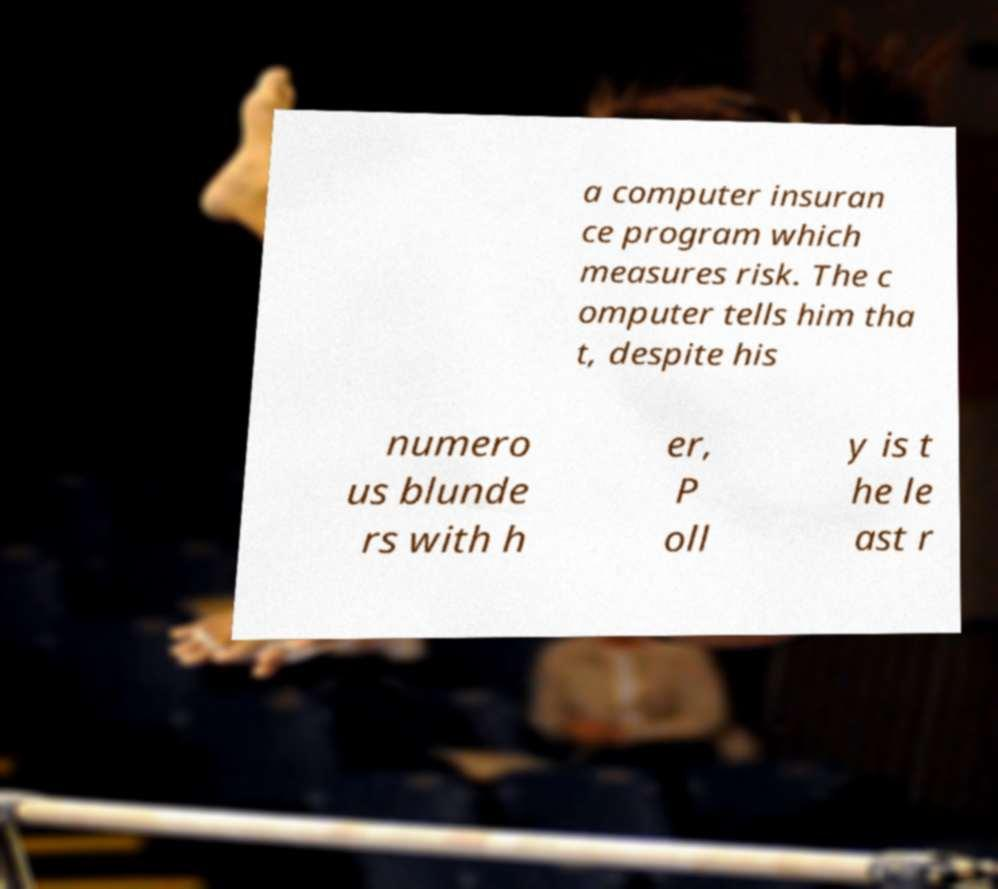Can you accurately transcribe the text from the provided image for me? a computer insuran ce program which measures risk. The c omputer tells him tha t, despite his numero us blunde rs with h er, P oll y is t he le ast r 